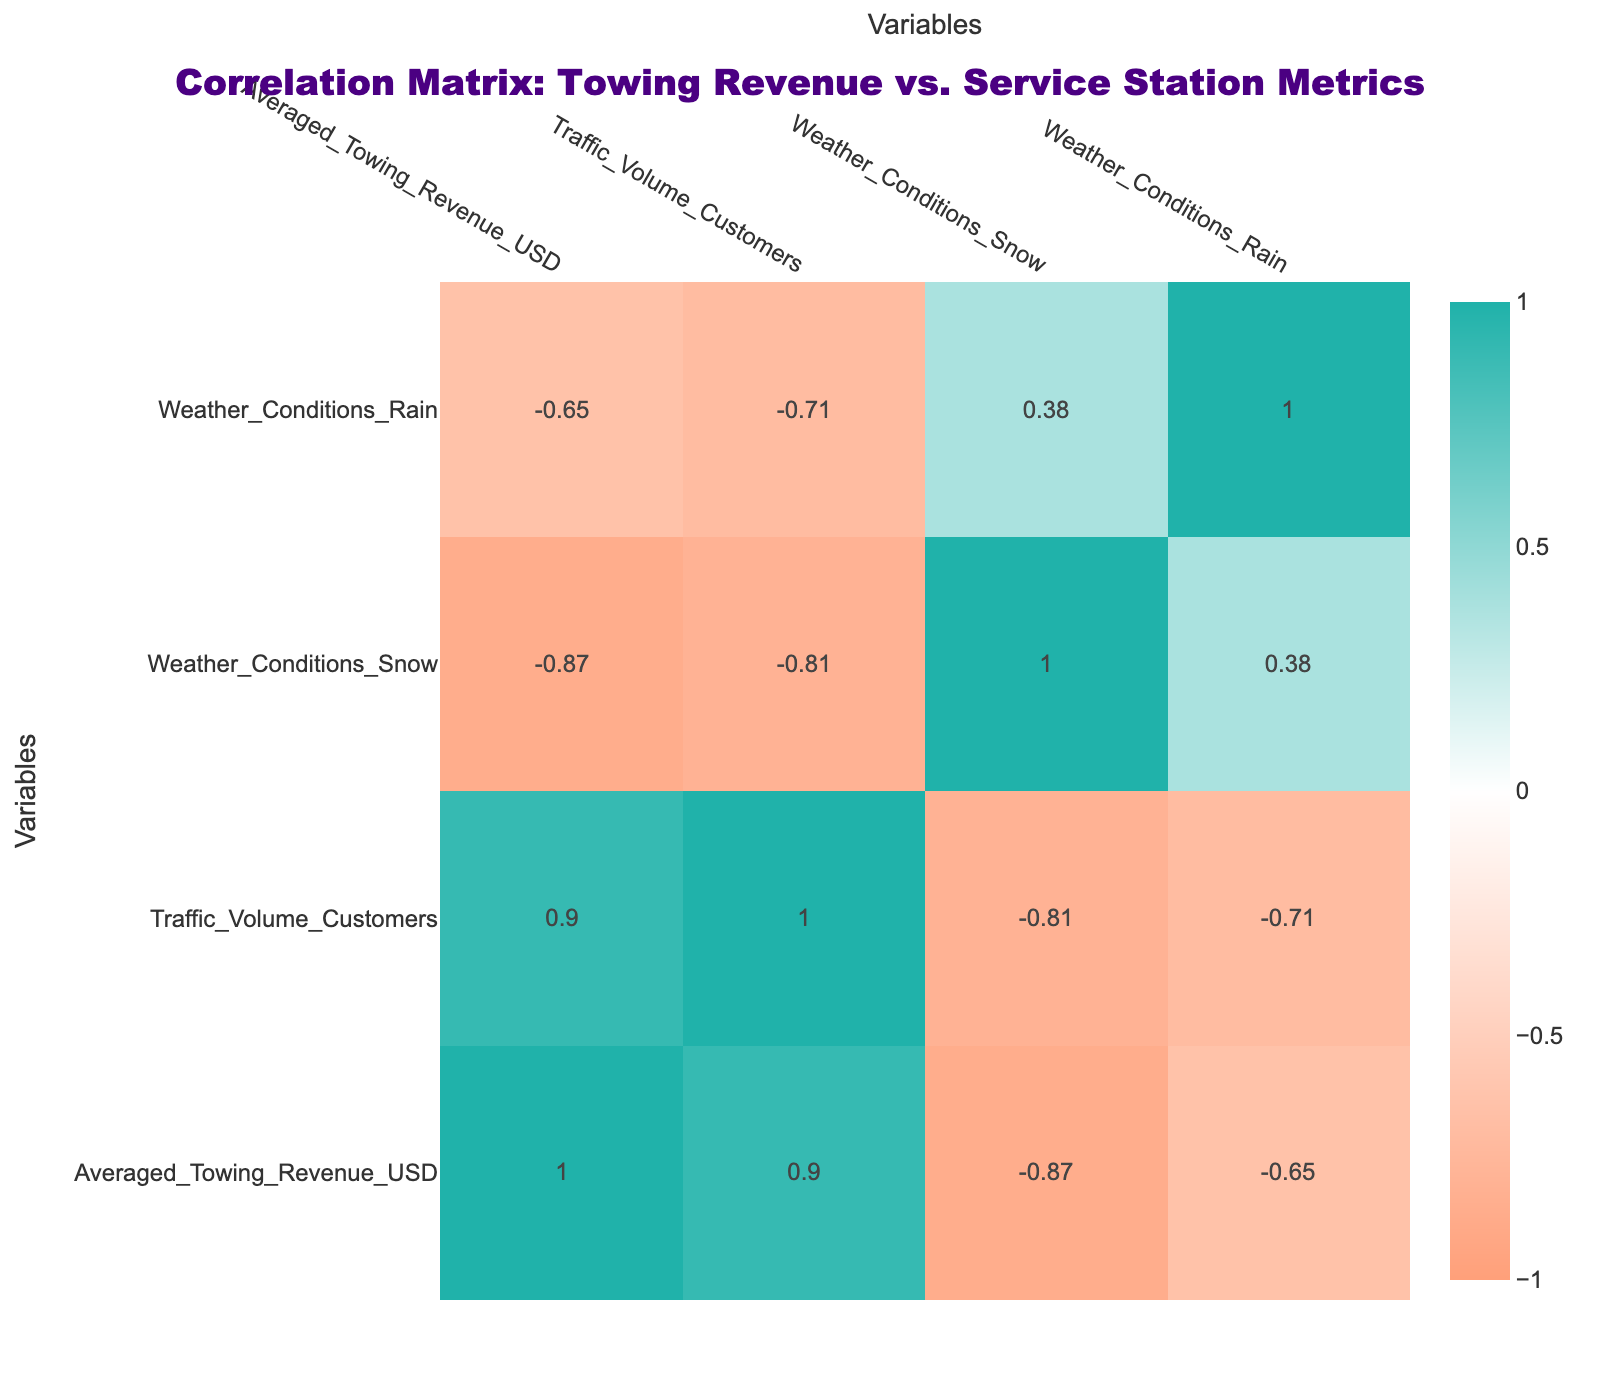What is the average towing revenue from May to August? To find the average towing revenue from May to August, we need to sum the revenue for each month in that range: May (2500) + June (2200) + July (2400) + August (2300) = 9400. Then, we divide by the number of months which is 4: 9400 / 4 = 2350.
Answer: 2350 In which month did the towing revenue reach its maximum? Looking at the Average Towing Revenue for each month, we find that July has the highest value at 2400.
Answer: July Is there a negative correlation between weather conditions and average towing revenue? To determine this, we look at the correlation values in the matrix. The correlation between Weather Conditions Snow and Average Towing Revenue is -0.36, and between Weather Conditions Rain and Average Towing Revenue is -0.20, indicating a slight negative correlation.
Answer: Yes Which month has the highest traffic volume of customers? By reviewing the Traffic Volume Customers column, we see that July has the highest value at 2400 customers.
Answer: July What is the average traffic volume for the second half of the year (July to December)? We need to sum the traffic volume for these months: July (2400) + August (2300) + September (2000) + October (1700) + November (1500) + December (1400) = 11600. We then divide by the number of months, which is 6: 11600 / 6 ≈ 1933.33.
Answer: 1933 During which month did towing revenue drop below 1700? Examining the table, we notice that the towing revenue dropped below 1700 in the months of November (1600) and December (1700).
Answer: November What is the correlation between traffic volume and average towing revenue? The correlation value between Traffic Volume Customers and Average Towing Revenue from the matrix is 0.90, indicating a strong positive correlation.
Answer: 0.90 Which month experienced the least amount of snowfall? By looking at the Weather Conditions Snow column, we see that June has the least amount of snowfall recorded at 0.
Answer: June 